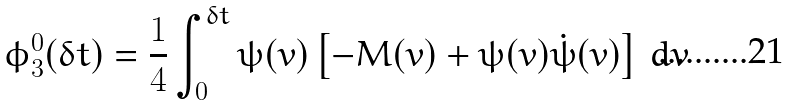Convert formula to latex. <formula><loc_0><loc_0><loc_500><loc_500>\phi ^ { 0 } _ { 3 } ( \delta t ) = \frac { 1 } { 4 } \int _ { 0 } ^ { \delta t } \psi ( v ) \left [ - M ( v ) + \psi ( v ) { \dot { \psi } } ( v ) \right ] \, d v</formula> 